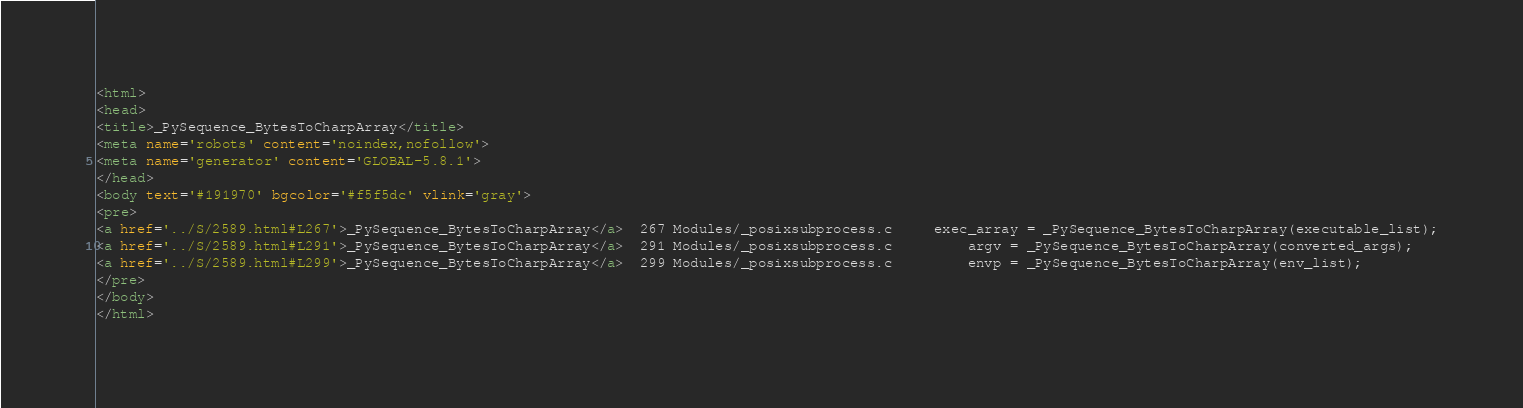Convert code to text. <code><loc_0><loc_0><loc_500><loc_500><_HTML_><html>
<head>
<title>_PySequence_BytesToCharpArray</title>
<meta name='robots' content='noindex,nofollow'>
<meta name='generator' content='GLOBAL-5.8.1'>
</head>
<body text='#191970' bgcolor='#f5f5dc' vlink='gray'>
<pre>
<a href='../S/2589.html#L267'>_PySequence_BytesToCharpArray</a>  267 Modules/_posixsubprocess.c     exec_array = _PySequence_BytesToCharpArray(executable_list);
<a href='../S/2589.html#L291'>_PySequence_BytesToCharpArray</a>  291 Modules/_posixsubprocess.c         argv = _PySequence_BytesToCharpArray(converted_args);
<a href='../S/2589.html#L299'>_PySequence_BytesToCharpArray</a>  299 Modules/_posixsubprocess.c         envp = _PySequence_BytesToCharpArray(env_list);
</pre>
</body>
</html>
</code> 